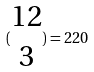<formula> <loc_0><loc_0><loc_500><loc_500>( \begin{matrix} 1 2 \\ 3 \end{matrix} ) = 2 2 0</formula> 